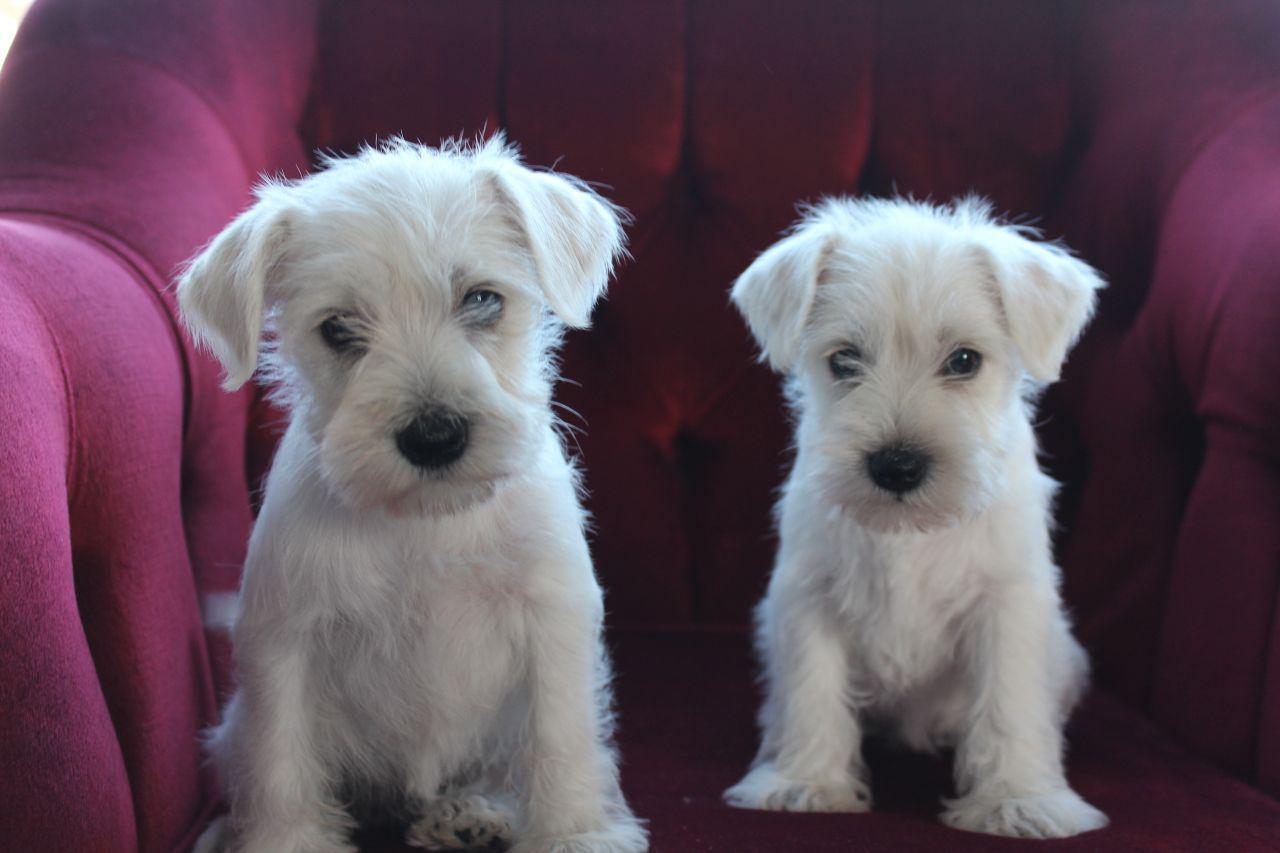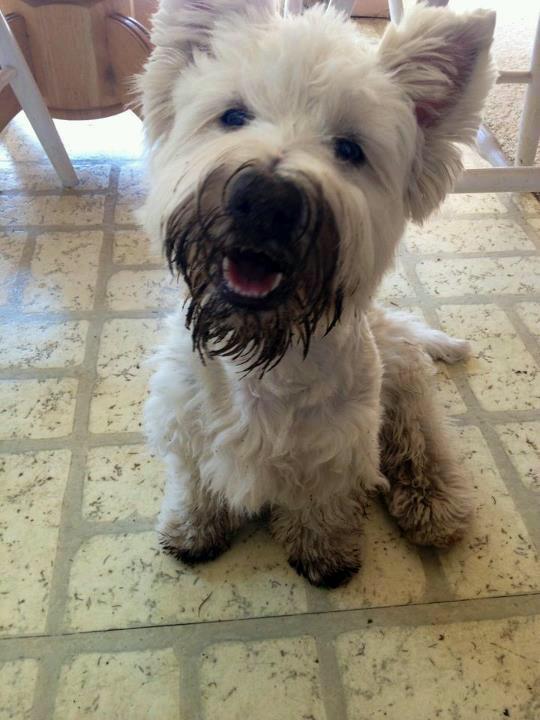The first image is the image on the left, the second image is the image on the right. For the images displayed, is the sentence "One puppy is sitting on tile flooring." factually correct? Answer yes or no. Yes. The first image is the image on the left, the second image is the image on the right. Examine the images to the left and right. Is the description "a single dog is sitting on a tile floor" accurate? Answer yes or no. Yes. 